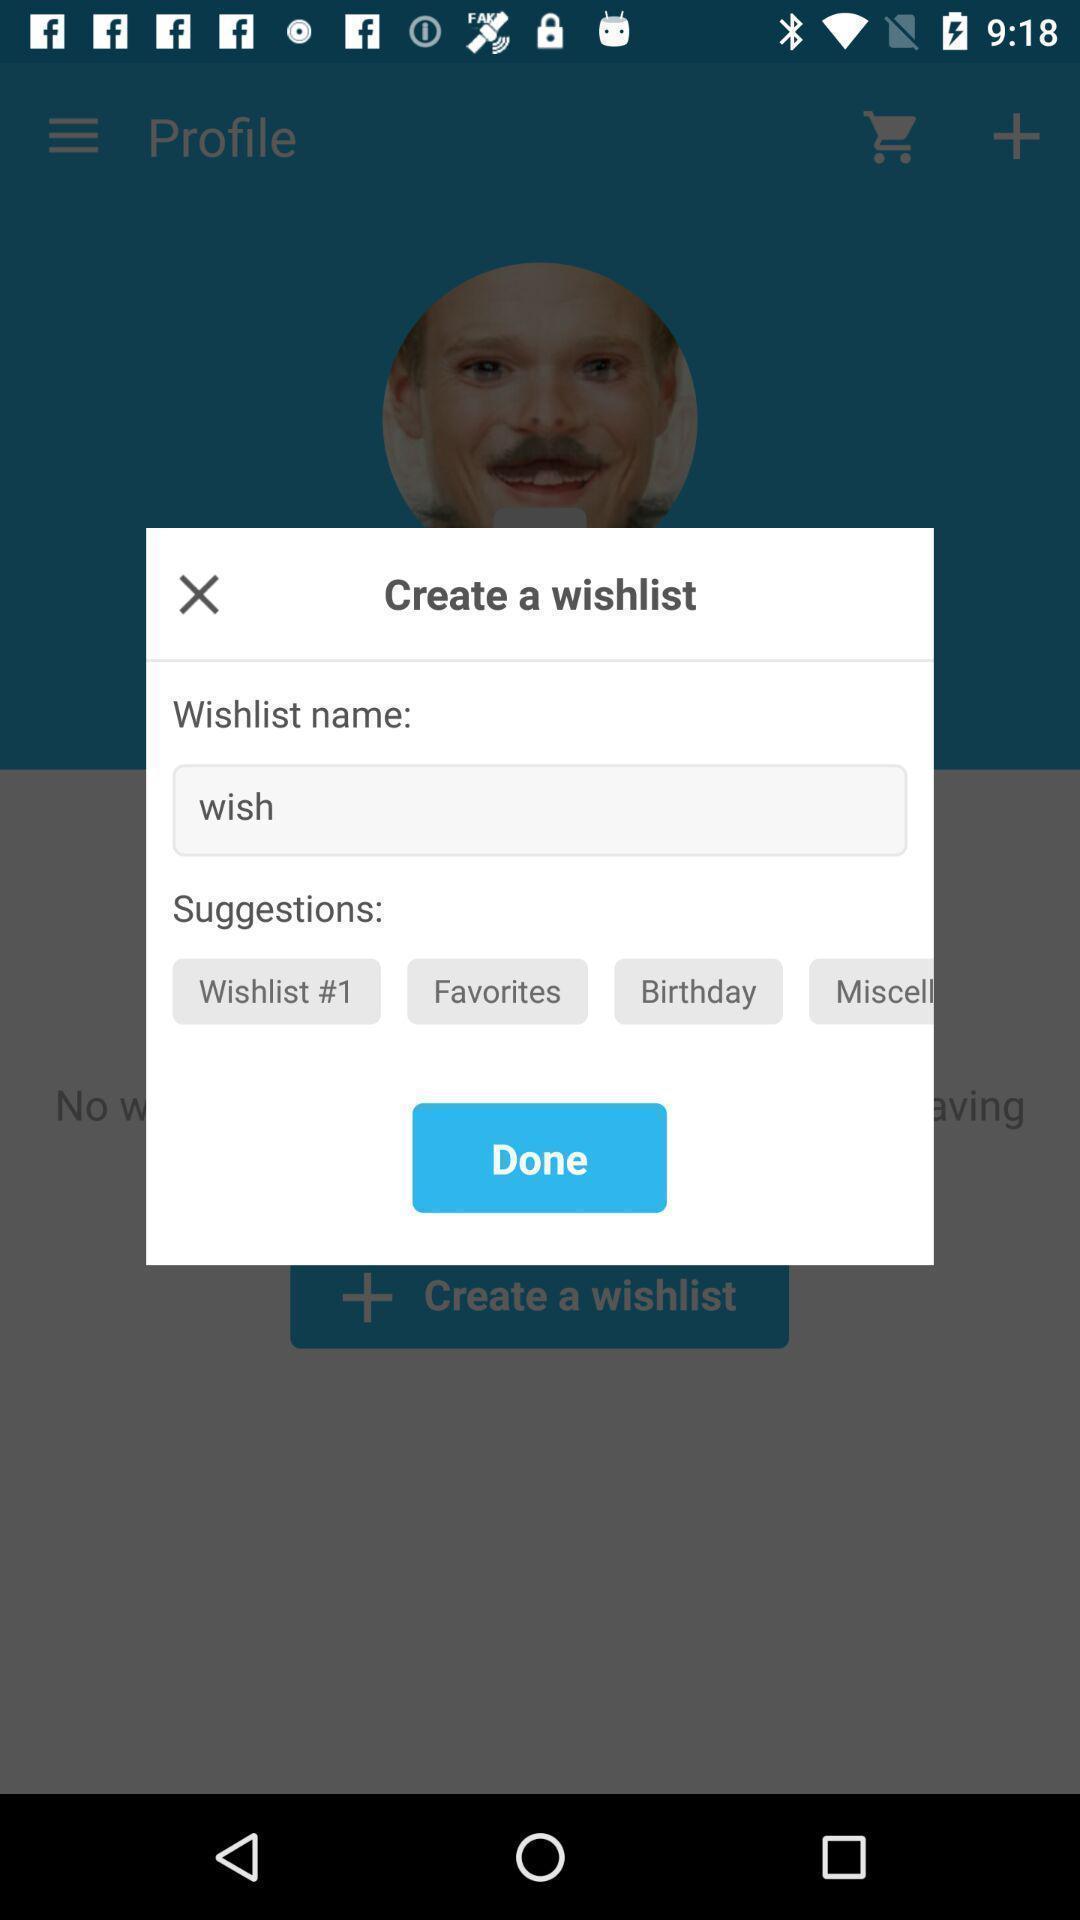Provide a description of this screenshot. Pop-up to create wish list. 